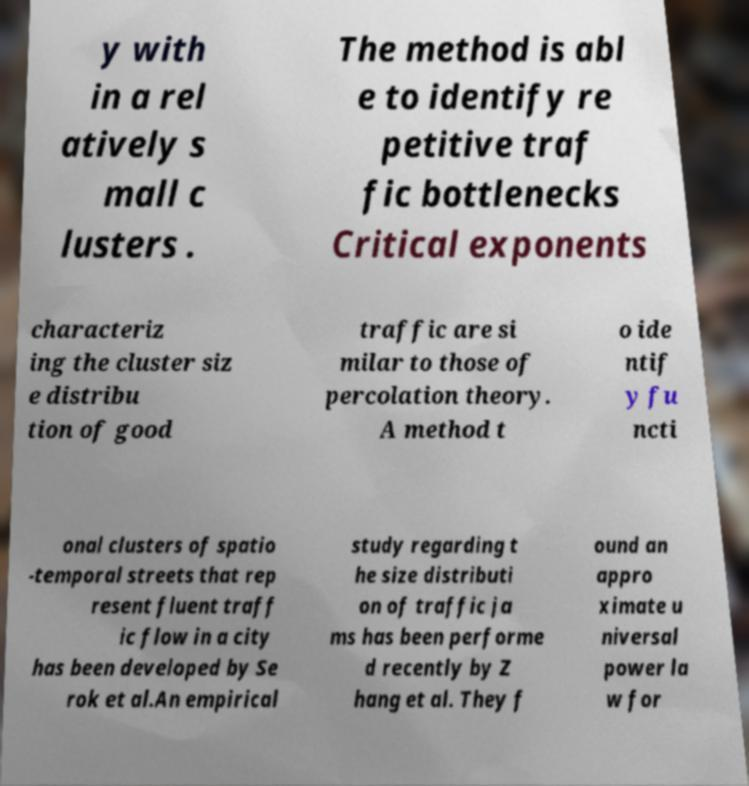What messages or text are displayed in this image? I need them in a readable, typed format. y with in a rel atively s mall c lusters . The method is abl e to identify re petitive traf fic bottlenecks Critical exponents characteriz ing the cluster siz e distribu tion of good traffic are si milar to those of percolation theory. A method t o ide ntif y fu ncti onal clusters of spatio -temporal streets that rep resent fluent traff ic flow in a city has been developed by Se rok et al.An empirical study regarding t he size distributi on of traffic ja ms has been performe d recently by Z hang et al. They f ound an appro ximate u niversal power la w for 